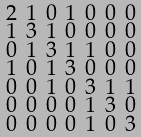<formula> <loc_0><loc_0><loc_500><loc_500>\begin{smallmatrix} 2 & 1 & 0 & 1 & 0 & 0 & 0 \\ 1 & 3 & 1 & 0 & 0 & 0 & 0 \\ 0 & 1 & 3 & 1 & 1 & 0 & 0 \\ 1 & 0 & 1 & 3 & 0 & 0 & 0 \\ 0 & 0 & 1 & 0 & 3 & 1 & 1 \\ 0 & 0 & 0 & 0 & 1 & 3 & 0 \\ 0 & 0 & 0 & 0 & 1 & 0 & 3 \end{smallmatrix}</formula> 